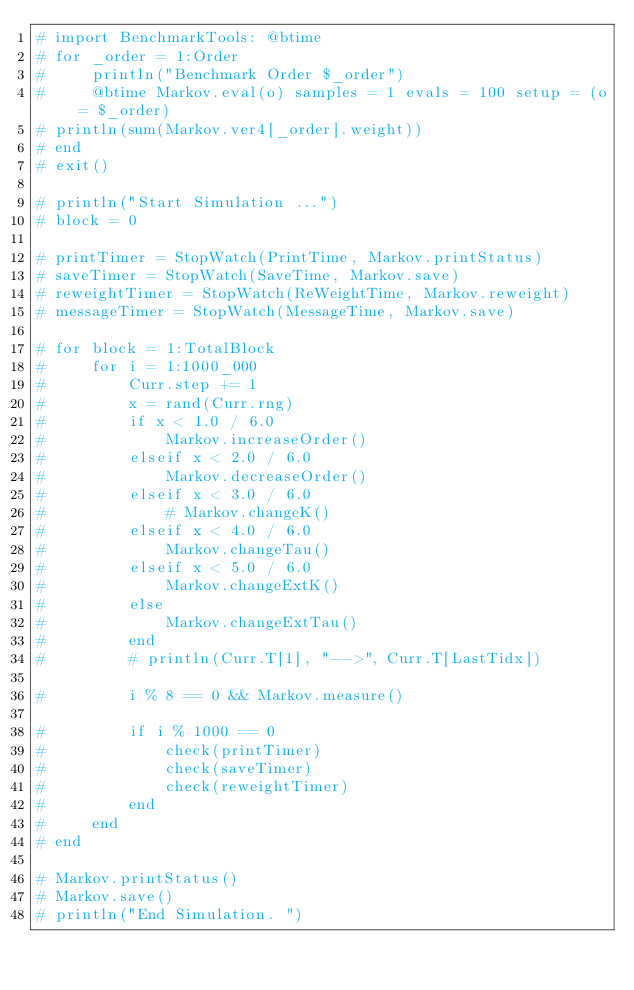Convert code to text. <code><loc_0><loc_0><loc_500><loc_500><_Julia_># import BenchmarkTools: @btime
# for _order = 1:Order
#     println("Benchmark Order $_order")
#     @btime Markov.eval(o) samples = 1 evals = 100 setup = (o = $_order)
# println(sum(Markov.ver4[_order].weight))
# end
# exit()

# println("Start Simulation ...")
# block = 0

# printTimer = StopWatch(PrintTime, Markov.printStatus)
# saveTimer = StopWatch(SaveTime, Markov.save)
# reweightTimer = StopWatch(ReWeightTime, Markov.reweight)
# messageTimer = StopWatch(MessageTime, Markov.save)

# for block = 1:TotalBlock
#     for i = 1:1000_000
#         Curr.step += 1
#         x = rand(Curr.rng)
#         if x < 1.0 / 6.0
#             Markov.increaseOrder()
#         elseif x < 2.0 / 6.0
#             Markov.decreaseOrder()
#         elseif x < 3.0 / 6.0
#             # Markov.changeK()
#         elseif x < 4.0 / 6.0
#             Markov.changeTau()
#         elseif x < 5.0 / 6.0
#             Markov.changeExtK()
#         else
#             Markov.changeExtTau()
#         end
#         # println(Curr.T[1], "-->", Curr.T[LastTidx])

#         i % 8 == 0 && Markov.measure()

#         if i % 1000 == 0
#             check(printTimer)
#             check(saveTimer)
#             check(reweightTimer)
#         end
#     end
# end

# Markov.printStatus()
# Markov.save()
# println("End Simulation. ")
</code> 